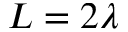<formula> <loc_0><loc_0><loc_500><loc_500>L = 2 \lambda</formula> 